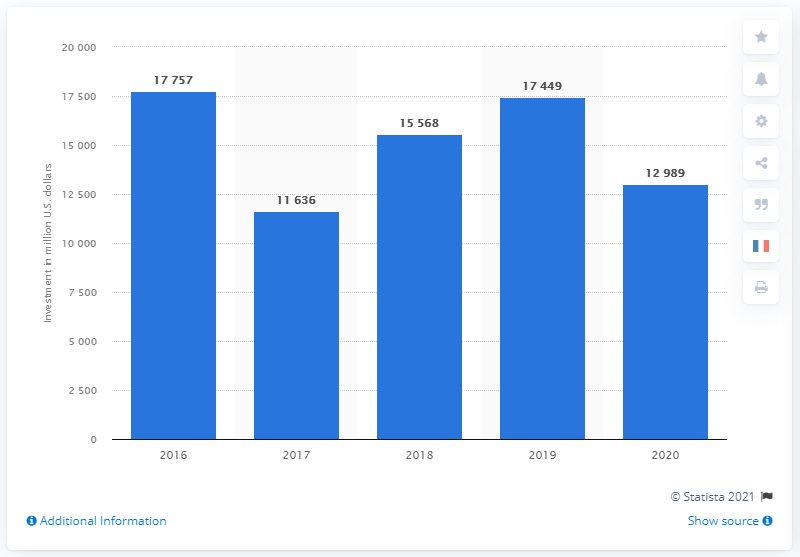Give some essential details in this illustration. Total SE invested a net amount of 12,989 in 2020. Total SE spent 17,449 in net investments in 2020. 